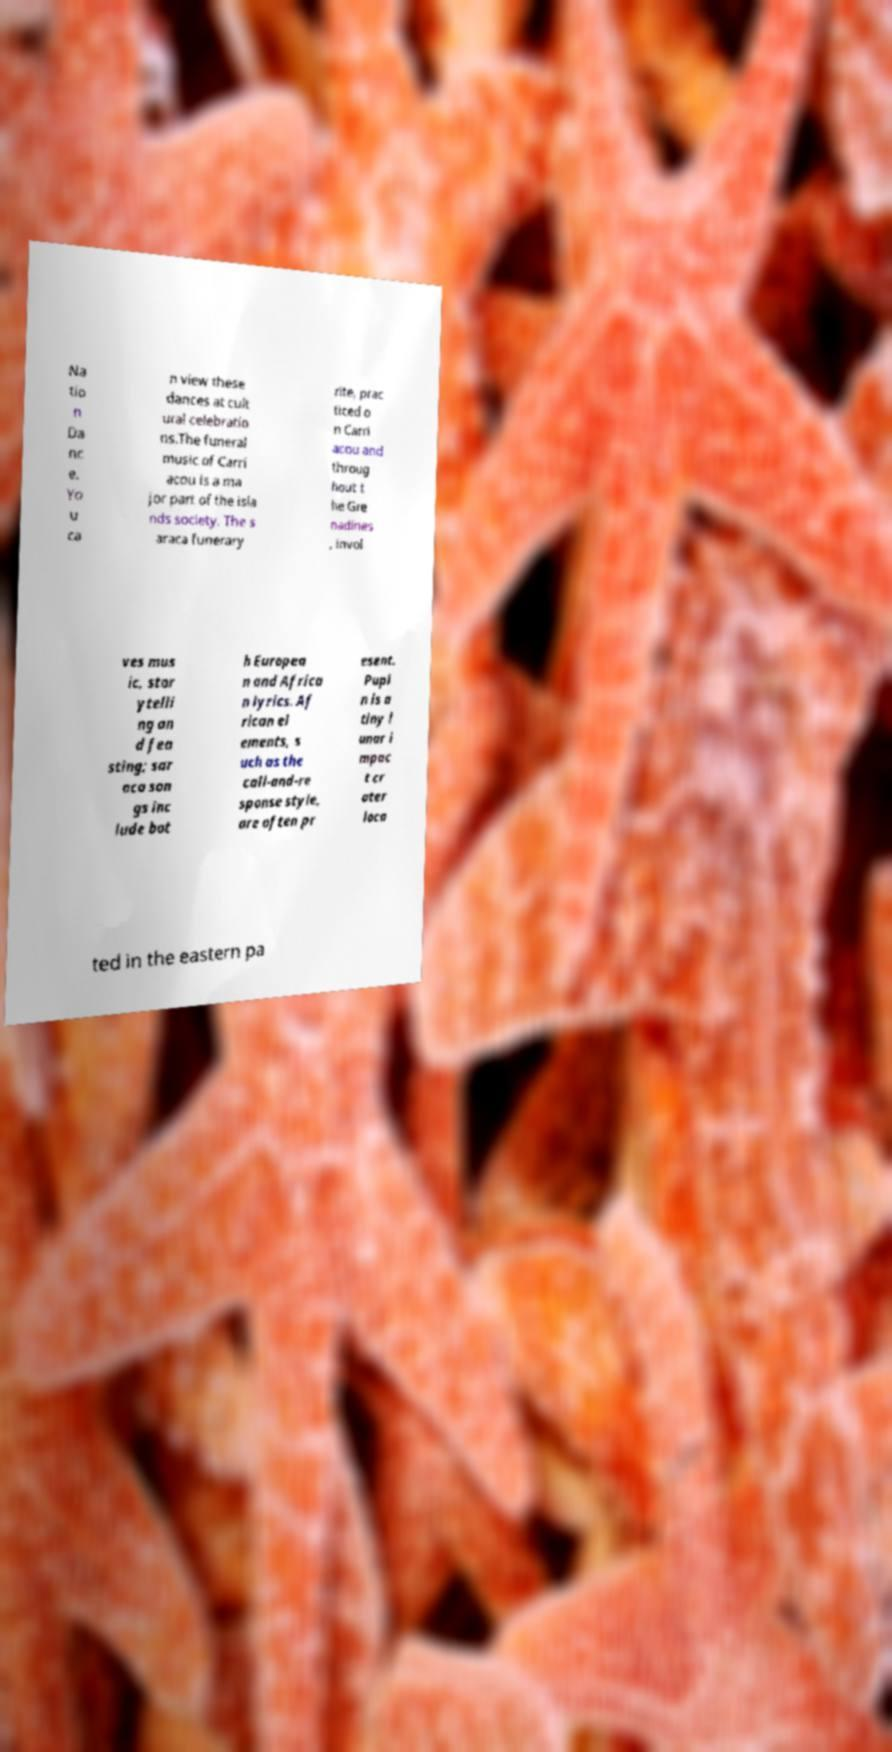Can you read and provide the text displayed in the image?This photo seems to have some interesting text. Can you extract and type it out for me? Na tio n Da nc e. Yo u ca n view these dances at cult ural celebratio ns.The funeral music of Carri acou is a ma jor part of the isla nds society. The s araca funerary rite, prac ticed o n Carri acou and throug hout t he Gre nadines , invol ves mus ic, stor ytelli ng an d fea sting; sar aca son gs inc lude bot h Europea n and Africa n lyrics. Af rican el ements, s uch as the call-and-re sponse style, are often pr esent. Pupi n is a tiny l unar i mpac t cr ater loca ted in the eastern pa 